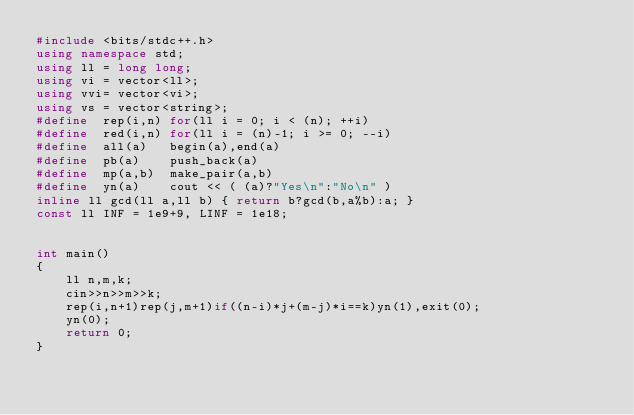Convert code to text. <code><loc_0><loc_0><loc_500><loc_500><_C++_>#include <bits/stdc++.h>
using namespace std;
using ll = long long;
using vi = vector<ll>;
using vvi= vector<vi>;
using vs = vector<string>;
#define  rep(i,n) for(ll i = 0; i < (n); ++i)
#define  red(i,n) for(ll i = (n)-1; i >= 0; --i)
#define  all(a)   begin(a),end(a)
#define  pb(a)    push_back(a)
#define  mp(a,b)  make_pair(a,b)
#define  yn(a)    cout << ( (a)?"Yes\n":"No\n" )
inline ll gcd(ll a,ll b) { return b?gcd(b,a%b):a; }
const ll INF = 1e9+9, LINF = 1e18;


int main()
{
    ll n,m,k;
    cin>>n>>m>>k;
    rep(i,n+1)rep(j,m+1)if((n-i)*j+(m-j)*i==k)yn(1),exit(0);
    yn(0);
    return 0;
}
</code> 